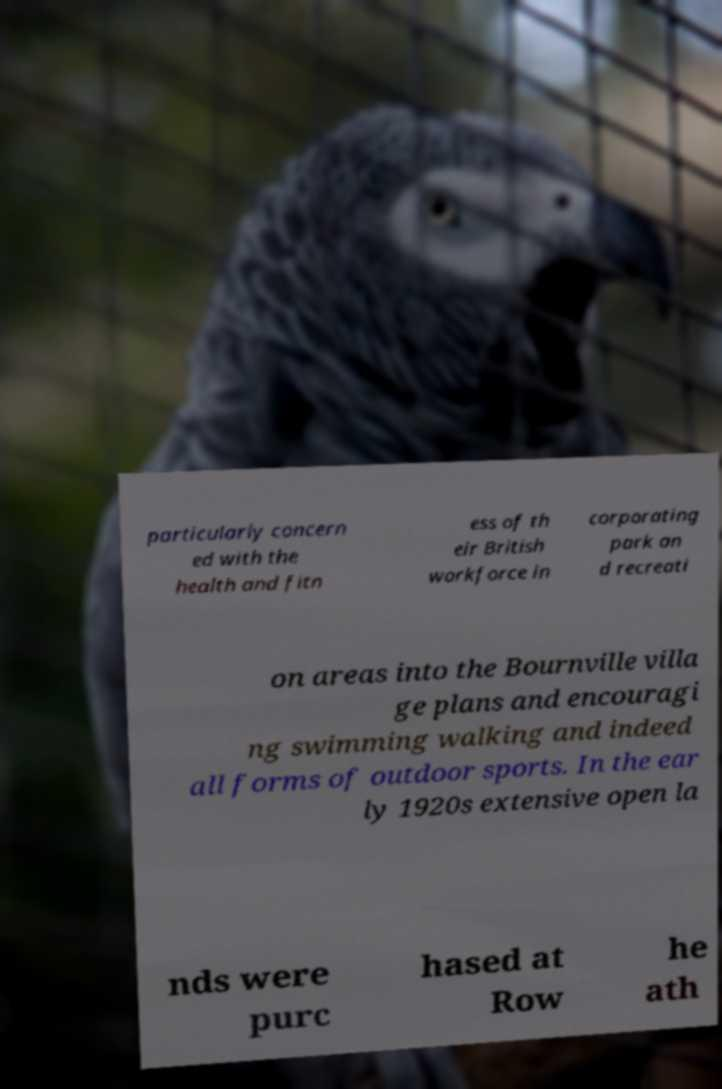I need the written content from this picture converted into text. Can you do that? particularly concern ed with the health and fitn ess of th eir British workforce in corporating park an d recreati on areas into the Bournville villa ge plans and encouragi ng swimming walking and indeed all forms of outdoor sports. In the ear ly 1920s extensive open la nds were purc hased at Row he ath 